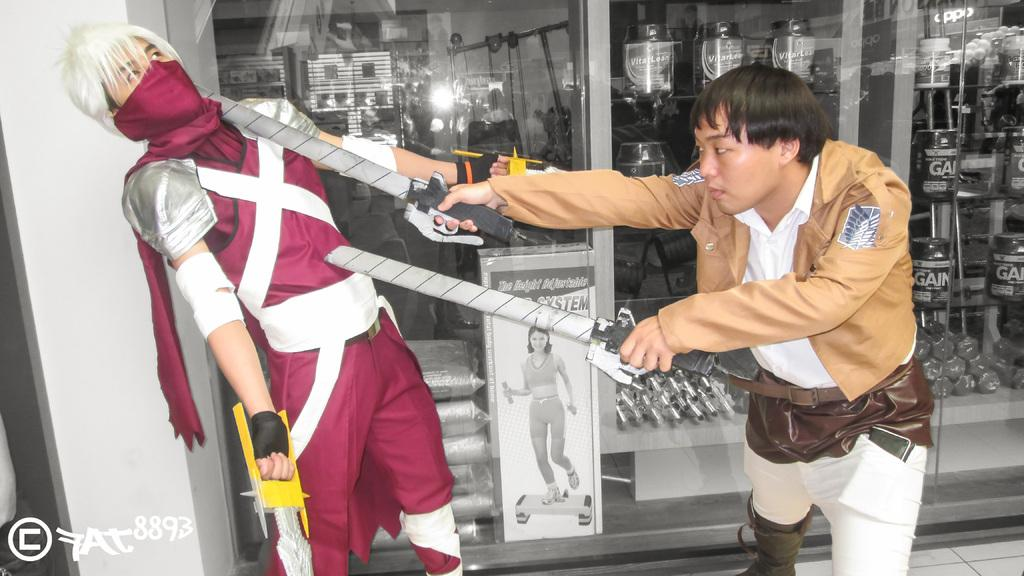How many people are the men are present in the image? There are two men in the image. What are the men holding in their hands? The men are holding swords in their hands. What are the men doing in the image? The men are fighting. What can be seen in the background of the image? There is a shop in the background of the image. What is inside the shop? There are objects in the shop. What is present in the bottom left corner of the image? There is text in the bottom left corner of the image. What type of soup is being served in the shop in the image? There is no soup or indication of a food service establishment in the image; it features two men fighting with swords. 